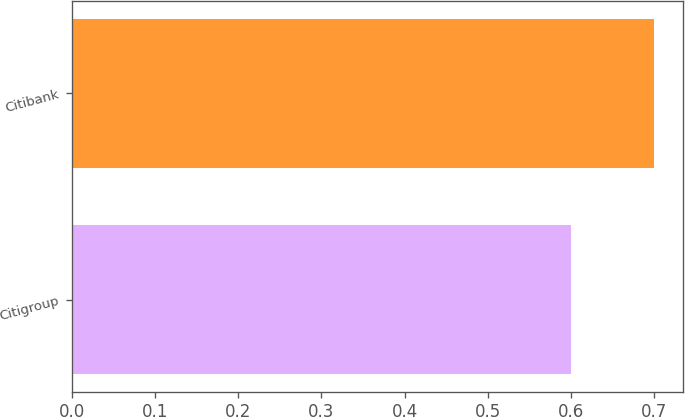Convert chart to OTSL. <chart><loc_0><loc_0><loc_500><loc_500><bar_chart><fcel>Citigroup<fcel>Citibank<nl><fcel>0.6<fcel>0.7<nl></chart> 